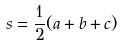Convert formula to latex. <formula><loc_0><loc_0><loc_500><loc_500>s = \frac { 1 } { 2 } ( a + b + c )</formula> 